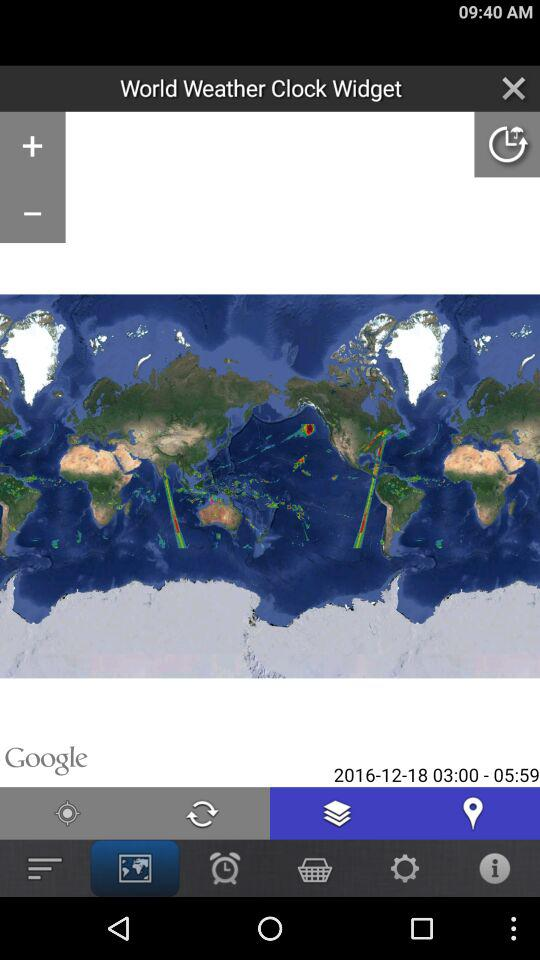What is the mentioned time range? The mentioned time range is from 03:00 to 05:59. 